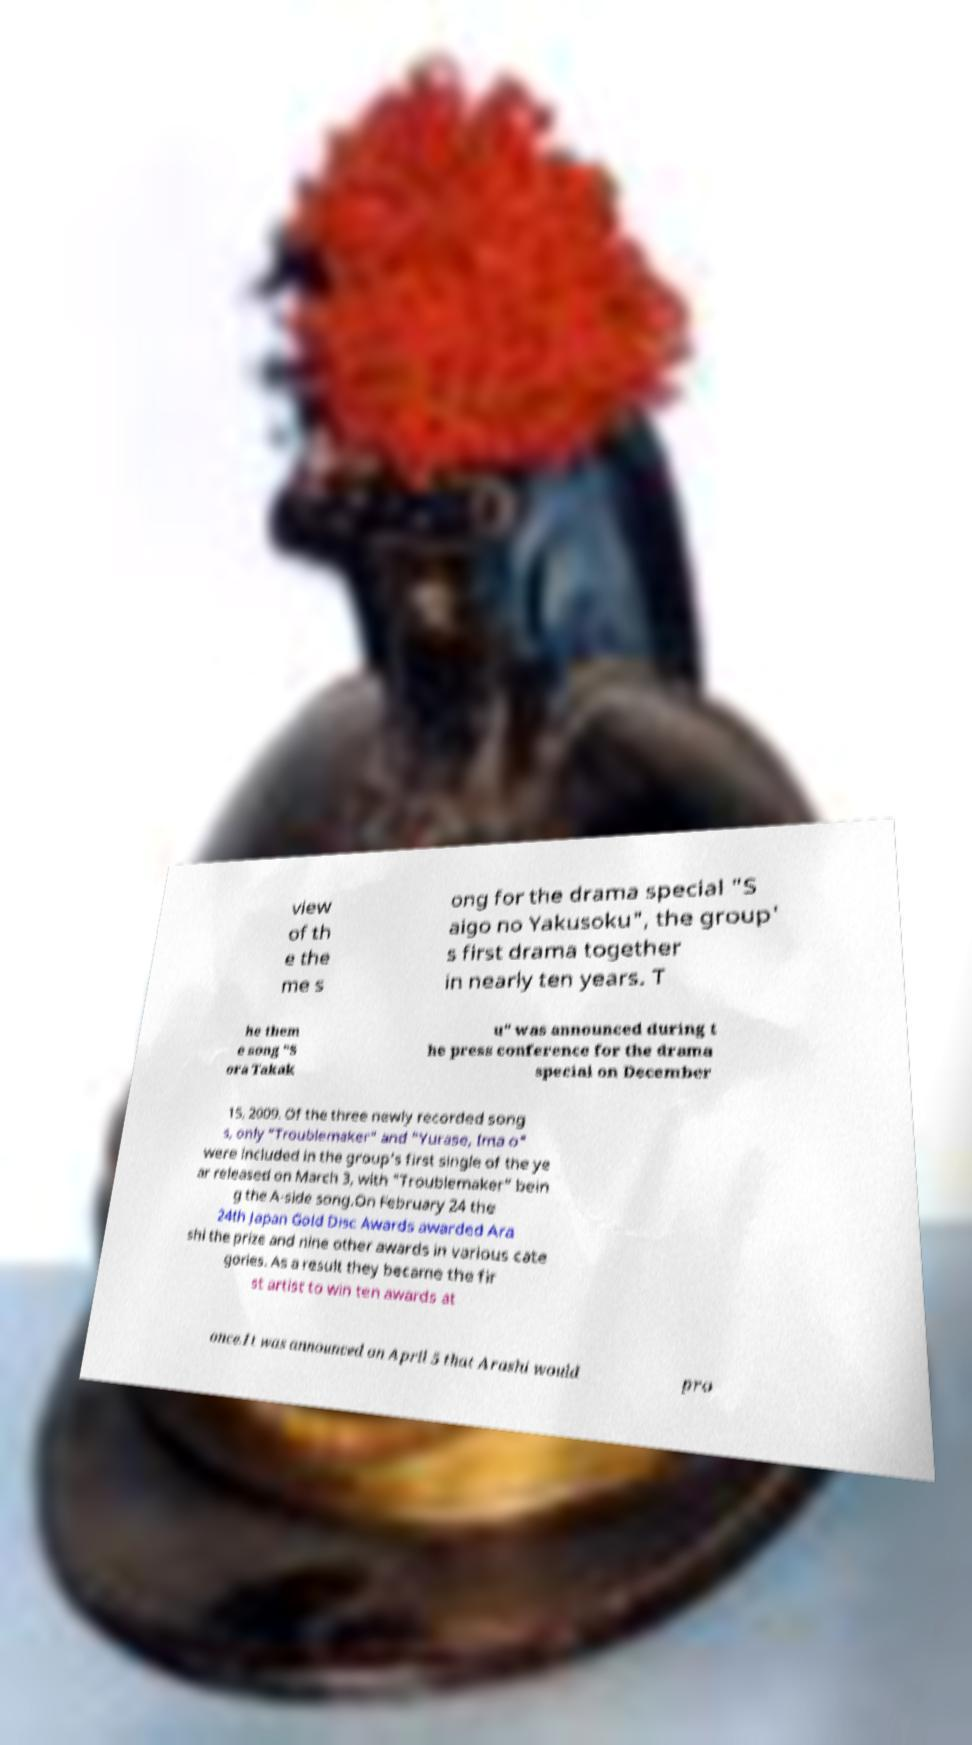Can you read and provide the text displayed in the image?This photo seems to have some interesting text. Can you extract and type it out for me? view of th e the me s ong for the drama special "S aigo no Yakusoku", the group' s first drama together in nearly ten years. T he them e song "S ora Takak u" was announced during t he press conference for the drama special on December 15, 2009. Of the three newly recorded song s, only "Troublemaker" and "Yurase, Ima o" were included in the group's first single of the ye ar released on March 3, with "Troublemaker" bein g the A-side song.On February 24 the 24th Japan Gold Disc Awards awarded Ara shi the prize and nine other awards in various cate gories. As a result they became the fir st artist to win ten awards at once.It was announced on April 5 that Arashi would pro 